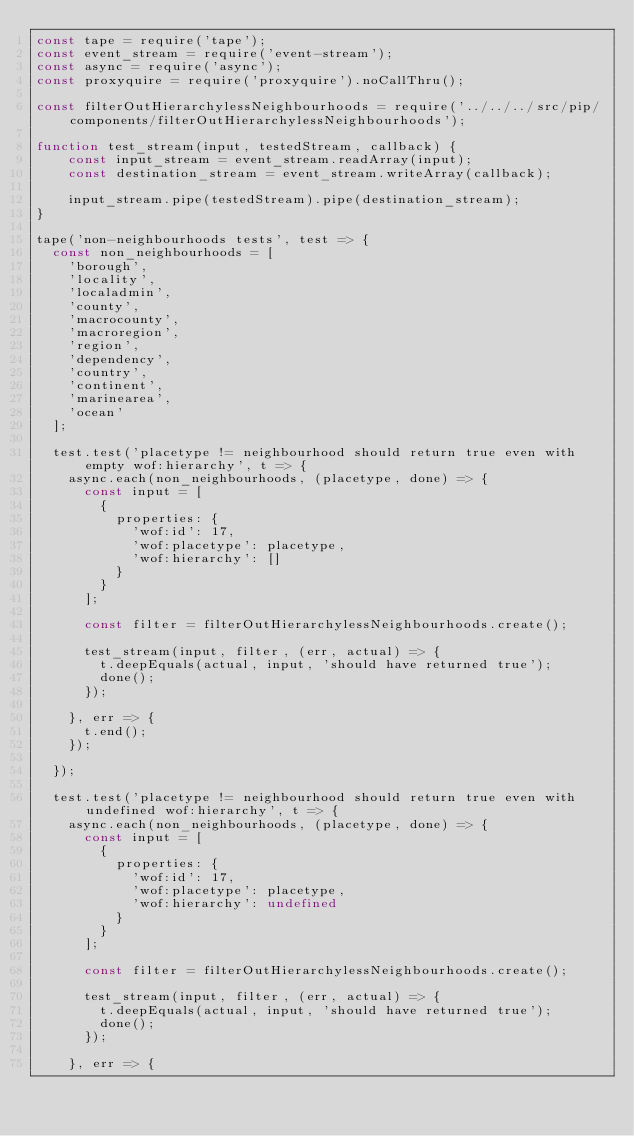Convert code to text. <code><loc_0><loc_0><loc_500><loc_500><_JavaScript_>const tape = require('tape');
const event_stream = require('event-stream');
const async = require('async');
const proxyquire = require('proxyquire').noCallThru();

const filterOutHierarchylessNeighbourhoods = require('../../../src/pip/components/filterOutHierarchylessNeighbourhoods');

function test_stream(input, testedStream, callback) {
    const input_stream = event_stream.readArray(input);
    const destination_stream = event_stream.writeArray(callback);

    input_stream.pipe(testedStream).pipe(destination_stream);
}

tape('non-neighbourhoods tests', test => {
  const non_neighbourhoods = [
    'borough',
    'locality',
    'localadmin',
    'county',
    'macrocounty',
    'macroregion',
    'region',
    'dependency',
    'country',
    'continent',
    'marinearea',
    'ocean'
  ];

	test.test('placetype != neighbourhood should return true even with empty wof:hierarchy', t => {
    async.each(non_neighbourhoods, (placetype, done) => {
      const input = [
        {
          properties: {
            'wof:id': 17,
            'wof:placetype': placetype,
            'wof:hierarchy': []
          }
        }
  		];

      const filter = filterOutHierarchylessNeighbourhoods.create();

  		test_stream(input, filter, (err, actual) => {
        t.deepEquals(actual, input, 'should have returned true');
        done();
      });

    }, err => {
      t.end();
    });

	});

  test.test('placetype != neighbourhood should return true even with undefined wof:hierarchy', t => {
    async.each(non_neighbourhoods, (placetype, done) => {
      const input = [
        {
          properties: {
            'wof:id': 17,
            'wof:placetype': placetype,
            'wof:hierarchy': undefined
          }
        }
  		];

      const filter = filterOutHierarchylessNeighbourhoods.create();

  		test_stream(input, filter, (err, actual) => {
        t.deepEquals(actual, input, 'should have returned true');
        done();
      });

    }, err => {</code> 